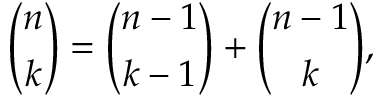Convert formula to latex. <formula><loc_0><loc_0><loc_500><loc_500>{ \binom { n } { k } } = { \binom { n - 1 } { k - 1 } } + { \binom { n - 1 } { k } } ,</formula> 